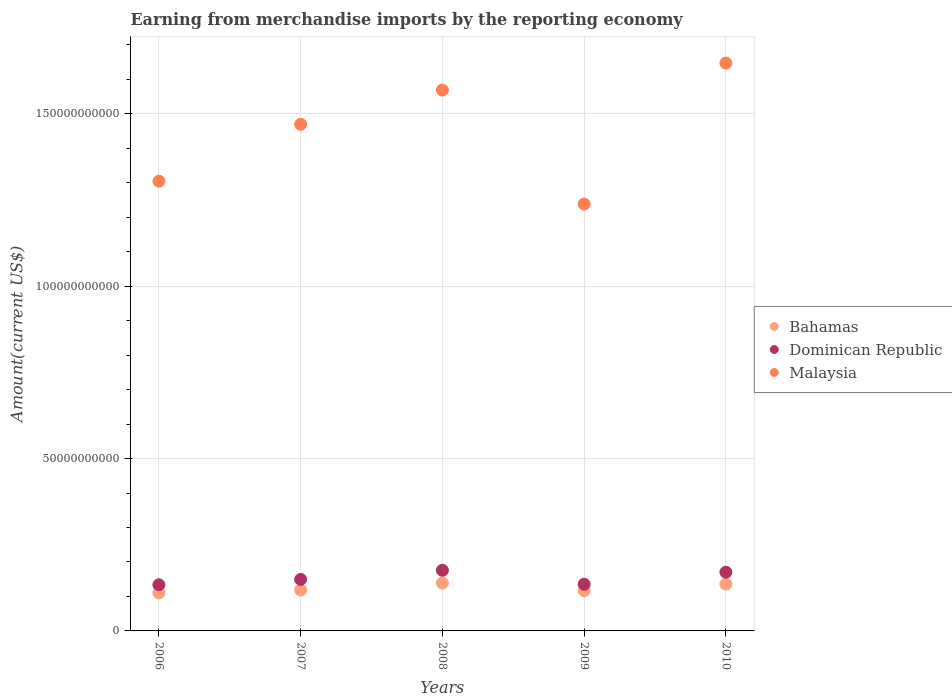Is the number of dotlines equal to the number of legend labels?
Your answer should be compact. Yes. What is the amount earned from merchandise imports in Dominican Republic in 2010?
Provide a short and direct response. 1.70e+1. Across all years, what is the maximum amount earned from merchandise imports in Dominican Republic?
Offer a very short reply. 1.76e+1. Across all years, what is the minimum amount earned from merchandise imports in Malaysia?
Provide a succinct answer. 1.24e+11. In which year was the amount earned from merchandise imports in Bahamas maximum?
Ensure brevity in your answer.  2008. What is the total amount earned from merchandise imports in Bahamas in the graph?
Offer a terse response. 6.21e+1. What is the difference between the amount earned from merchandise imports in Malaysia in 2007 and that in 2010?
Offer a terse response. -1.78e+1. What is the difference between the amount earned from merchandise imports in Dominican Republic in 2008 and the amount earned from merchandise imports in Bahamas in 2010?
Provide a succinct answer. 4.00e+09. What is the average amount earned from merchandise imports in Bahamas per year?
Your answer should be very brief. 1.24e+1. In the year 2009, what is the difference between the amount earned from merchandise imports in Bahamas and amount earned from merchandise imports in Malaysia?
Offer a terse response. -1.12e+11. In how many years, is the amount earned from merchandise imports in Bahamas greater than 160000000000 US$?
Your response must be concise. 0. What is the ratio of the amount earned from merchandise imports in Malaysia in 2007 to that in 2008?
Provide a short and direct response. 0.94. Is the amount earned from merchandise imports in Dominican Republic in 2006 less than that in 2007?
Provide a short and direct response. Yes. Is the difference between the amount earned from merchandise imports in Bahamas in 2007 and 2008 greater than the difference between the amount earned from merchandise imports in Malaysia in 2007 and 2008?
Your response must be concise. Yes. What is the difference between the highest and the second highest amount earned from merchandise imports in Bahamas?
Your response must be concise. 3.21e+08. What is the difference between the highest and the lowest amount earned from merchandise imports in Dominican Republic?
Your answer should be compact. 4.20e+09. Is it the case that in every year, the sum of the amount earned from merchandise imports in Malaysia and amount earned from merchandise imports in Dominican Republic  is greater than the amount earned from merchandise imports in Bahamas?
Keep it short and to the point. Yes. Is the amount earned from merchandise imports in Dominican Republic strictly less than the amount earned from merchandise imports in Bahamas over the years?
Ensure brevity in your answer.  No. What is the difference between two consecutive major ticks on the Y-axis?
Keep it short and to the point. 5.00e+1. Are the values on the major ticks of Y-axis written in scientific E-notation?
Provide a short and direct response. No. Does the graph contain any zero values?
Give a very brief answer. No. Where does the legend appear in the graph?
Give a very brief answer. Center right. What is the title of the graph?
Offer a terse response. Earning from merchandise imports by the reporting economy. What is the label or title of the Y-axis?
Offer a terse response. Amount(current US$). What is the Amount(current US$) in Bahamas in 2006?
Your response must be concise. 1.10e+1. What is the Amount(current US$) of Dominican Republic in 2006?
Offer a terse response. 1.34e+1. What is the Amount(current US$) in Malaysia in 2006?
Offer a terse response. 1.30e+11. What is the Amount(current US$) in Bahamas in 2007?
Keep it short and to the point. 1.19e+1. What is the Amount(current US$) in Dominican Republic in 2007?
Make the answer very short. 1.50e+1. What is the Amount(current US$) in Malaysia in 2007?
Your answer should be very brief. 1.47e+11. What is the Amount(current US$) of Bahamas in 2008?
Ensure brevity in your answer.  1.39e+1. What is the Amount(current US$) of Dominican Republic in 2008?
Provide a succinct answer. 1.76e+1. What is the Amount(current US$) of Malaysia in 2008?
Provide a succinct answer. 1.57e+11. What is the Amount(current US$) in Bahamas in 2009?
Offer a terse response. 1.17e+1. What is the Amount(current US$) of Dominican Republic in 2009?
Offer a very short reply. 1.35e+1. What is the Amount(current US$) in Malaysia in 2009?
Your response must be concise. 1.24e+11. What is the Amount(current US$) of Bahamas in 2010?
Offer a terse response. 1.36e+1. What is the Amount(current US$) in Dominican Republic in 2010?
Provide a succinct answer. 1.70e+1. What is the Amount(current US$) of Malaysia in 2010?
Make the answer very short. 1.65e+11. Across all years, what is the maximum Amount(current US$) of Bahamas?
Provide a short and direct response. 1.39e+1. Across all years, what is the maximum Amount(current US$) in Dominican Republic?
Your answer should be very brief. 1.76e+1. Across all years, what is the maximum Amount(current US$) in Malaysia?
Provide a succinct answer. 1.65e+11. Across all years, what is the minimum Amount(current US$) in Bahamas?
Your answer should be compact. 1.10e+1. Across all years, what is the minimum Amount(current US$) of Dominican Republic?
Your answer should be very brief. 1.34e+1. Across all years, what is the minimum Amount(current US$) of Malaysia?
Make the answer very short. 1.24e+11. What is the total Amount(current US$) of Bahamas in the graph?
Your response must be concise. 6.21e+1. What is the total Amount(current US$) in Dominican Republic in the graph?
Your answer should be compact. 7.65e+1. What is the total Amount(current US$) of Malaysia in the graph?
Your response must be concise. 7.23e+11. What is the difference between the Amount(current US$) of Bahamas in 2006 and that in 2007?
Your response must be concise. -8.22e+08. What is the difference between the Amount(current US$) of Dominican Republic in 2006 and that in 2007?
Your answer should be very brief. -1.56e+09. What is the difference between the Amount(current US$) in Malaysia in 2006 and that in 2007?
Make the answer very short. -1.65e+1. What is the difference between the Amount(current US$) of Bahamas in 2006 and that in 2008?
Keep it short and to the point. -2.87e+09. What is the difference between the Amount(current US$) of Dominican Republic in 2006 and that in 2008?
Provide a short and direct response. -4.20e+09. What is the difference between the Amount(current US$) of Malaysia in 2006 and that in 2008?
Your response must be concise. -2.64e+1. What is the difference between the Amount(current US$) in Bahamas in 2006 and that in 2009?
Make the answer very short. -6.40e+08. What is the difference between the Amount(current US$) in Dominican Republic in 2006 and that in 2009?
Provide a succinct answer. -1.34e+08. What is the difference between the Amount(current US$) of Malaysia in 2006 and that in 2009?
Your answer should be compact. 6.65e+09. What is the difference between the Amount(current US$) of Bahamas in 2006 and that in 2010?
Provide a short and direct response. -2.55e+09. What is the difference between the Amount(current US$) of Dominican Republic in 2006 and that in 2010?
Your answer should be very brief. -3.65e+09. What is the difference between the Amount(current US$) in Malaysia in 2006 and that in 2010?
Make the answer very short. -3.43e+1. What is the difference between the Amount(current US$) in Bahamas in 2007 and that in 2008?
Provide a short and direct response. -2.05e+09. What is the difference between the Amount(current US$) in Dominican Republic in 2007 and that in 2008?
Provide a short and direct response. -2.64e+09. What is the difference between the Amount(current US$) of Malaysia in 2007 and that in 2008?
Give a very brief answer. -9.91e+09. What is the difference between the Amount(current US$) in Bahamas in 2007 and that in 2009?
Your answer should be very brief. 1.82e+08. What is the difference between the Amount(current US$) in Dominican Republic in 2007 and that in 2009?
Offer a very short reply. 1.43e+09. What is the difference between the Amount(current US$) in Malaysia in 2007 and that in 2009?
Give a very brief answer. 2.32e+1. What is the difference between the Amount(current US$) in Bahamas in 2007 and that in 2010?
Offer a terse response. -1.73e+09. What is the difference between the Amount(current US$) in Dominican Republic in 2007 and that in 2010?
Make the answer very short. -2.08e+09. What is the difference between the Amount(current US$) of Malaysia in 2007 and that in 2010?
Offer a very short reply. -1.78e+1. What is the difference between the Amount(current US$) of Bahamas in 2008 and that in 2009?
Offer a very short reply. 2.23e+09. What is the difference between the Amount(current US$) of Dominican Republic in 2008 and that in 2009?
Your answer should be compact. 4.07e+09. What is the difference between the Amount(current US$) in Malaysia in 2008 and that in 2009?
Keep it short and to the point. 3.31e+1. What is the difference between the Amount(current US$) of Bahamas in 2008 and that in 2010?
Give a very brief answer. 3.21e+08. What is the difference between the Amount(current US$) of Dominican Republic in 2008 and that in 2010?
Provide a succinct answer. 5.54e+08. What is the difference between the Amount(current US$) of Malaysia in 2008 and that in 2010?
Offer a terse response. -7.84e+09. What is the difference between the Amount(current US$) of Bahamas in 2009 and that in 2010?
Keep it short and to the point. -1.91e+09. What is the difference between the Amount(current US$) in Dominican Republic in 2009 and that in 2010?
Offer a very short reply. -3.51e+09. What is the difference between the Amount(current US$) in Malaysia in 2009 and that in 2010?
Provide a short and direct response. -4.09e+1. What is the difference between the Amount(current US$) in Bahamas in 2006 and the Amount(current US$) in Dominican Republic in 2007?
Your answer should be very brief. -3.91e+09. What is the difference between the Amount(current US$) in Bahamas in 2006 and the Amount(current US$) in Malaysia in 2007?
Offer a very short reply. -1.36e+11. What is the difference between the Amount(current US$) in Dominican Republic in 2006 and the Amount(current US$) in Malaysia in 2007?
Offer a very short reply. -1.34e+11. What is the difference between the Amount(current US$) in Bahamas in 2006 and the Amount(current US$) in Dominican Republic in 2008?
Provide a succinct answer. -6.55e+09. What is the difference between the Amount(current US$) in Bahamas in 2006 and the Amount(current US$) in Malaysia in 2008?
Your answer should be very brief. -1.46e+11. What is the difference between the Amount(current US$) of Dominican Republic in 2006 and the Amount(current US$) of Malaysia in 2008?
Your response must be concise. -1.44e+11. What is the difference between the Amount(current US$) in Bahamas in 2006 and the Amount(current US$) in Dominican Republic in 2009?
Your answer should be compact. -2.48e+09. What is the difference between the Amount(current US$) in Bahamas in 2006 and the Amount(current US$) in Malaysia in 2009?
Provide a short and direct response. -1.13e+11. What is the difference between the Amount(current US$) in Dominican Republic in 2006 and the Amount(current US$) in Malaysia in 2009?
Ensure brevity in your answer.  -1.10e+11. What is the difference between the Amount(current US$) in Bahamas in 2006 and the Amount(current US$) in Dominican Republic in 2010?
Your response must be concise. -5.99e+09. What is the difference between the Amount(current US$) in Bahamas in 2006 and the Amount(current US$) in Malaysia in 2010?
Give a very brief answer. -1.54e+11. What is the difference between the Amount(current US$) of Dominican Republic in 2006 and the Amount(current US$) of Malaysia in 2010?
Your answer should be compact. -1.51e+11. What is the difference between the Amount(current US$) of Bahamas in 2007 and the Amount(current US$) of Dominican Republic in 2008?
Your answer should be very brief. -5.73e+09. What is the difference between the Amount(current US$) of Bahamas in 2007 and the Amount(current US$) of Malaysia in 2008?
Make the answer very short. -1.45e+11. What is the difference between the Amount(current US$) of Dominican Republic in 2007 and the Amount(current US$) of Malaysia in 2008?
Keep it short and to the point. -1.42e+11. What is the difference between the Amount(current US$) of Bahamas in 2007 and the Amount(current US$) of Dominican Republic in 2009?
Offer a very short reply. -1.66e+09. What is the difference between the Amount(current US$) of Bahamas in 2007 and the Amount(current US$) of Malaysia in 2009?
Ensure brevity in your answer.  -1.12e+11. What is the difference between the Amount(current US$) of Dominican Republic in 2007 and the Amount(current US$) of Malaysia in 2009?
Your response must be concise. -1.09e+11. What is the difference between the Amount(current US$) of Bahamas in 2007 and the Amount(current US$) of Dominican Republic in 2010?
Your answer should be very brief. -5.17e+09. What is the difference between the Amount(current US$) in Bahamas in 2007 and the Amount(current US$) in Malaysia in 2010?
Keep it short and to the point. -1.53e+11. What is the difference between the Amount(current US$) in Dominican Republic in 2007 and the Amount(current US$) in Malaysia in 2010?
Make the answer very short. -1.50e+11. What is the difference between the Amount(current US$) in Bahamas in 2008 and the Amount(current US$) in Dominican Republic in 2009?
Keep it short and to the point. 3.92e+08. What is the difference between the Amount(current US$) of Bahamas in 2008 and the Amount(current US$) of Malaysia in 2009?
Provide a short and direct response. -1.10e+11. What is the difference between the Amount(current US$) of Dominican Republic in 2008 and the Amount(current US$) of Malaysia in 2009?
Provide a succinct answer. -1.06e+11. What is the difference between the Amount(current US$) of Bahamas in 2008 and the Amount(current US$) of Dominican Republic in 2010?
Provide a short and direct response. -3.12e+09. What is the difference between the Amount(current US$) of Bahamas in 2008 and the Amount(current US$) of Malaysia in 2010?
Your response must be concise. -1.51e+11. What is the difference between the Amount(current US$) in Dominican Republic in 2008 and the Amount(current US$) in Malaysia in 2010?
Keep it short and to the point. -1.47e+11. What is the difference between the Amount(current US$) of Bahamas in 2009 and the Amount(current US$) of Dominican Republic in 2010?
Provide a short and direct response. -5.35e+09. What is the difference between the Amount(current US$) in Bahamas in 2009 and the Amount(current US$) in Malaysia in 2010?
Ensure brevity in your answer.  -1.53e+11. What is the difference between the Amount(current US$) of Dominican Republic in 2009 and the Amount(current US$) of Malaysia in 2010?
Provide a succinct answer. -1.51e+11. What is the average Amount(current US$) of Bahamas per year?
Provide a succinct answer. 1.24e+1. What is the average Amount(current US$) of Dominican Republic per year?
Offer a very short reply. 1.53e+1. What is the average Amount(current US$) of Malaysia per year?
Your answer should be very brief. 1.45e+11. In the year 2006, what is the difference between the Amount(current US$) of Bahamas and Amount(current US$) of Dominican Republic?
Your answer should be very brief. -2.35e+09. In the year 2006, what is the difference between the Amount(current US$) of Bahamas and Amount(current US$) of Malaysia?
Make the answer very short. -1.19e+11. In the year 2006, what is the difference between the Amount(current US$) of Dominican Republic and Amount(current US$) of Malaysia?
Offer a terse response. -1.17e+11. In the year 2007, what is the difference between the Amount(current US$) in Bahamas and Amount(current US$) in Dominican Republic?
Offer a terse response. -3.09e+09. In the year 2007, what is the difference between the Amount(current US$) in Bahamas and Amount(current US$) in Malaysia?
Offer a terse response. -1.35e+11. In the year 2007, what is the difference between the Amount(current US$) of Dominican Republic and Amount(current US$) of Malaysia?
Make the answer very short. -1.32e+11. In the year 2008, what is the difference between the Amount(current US$) in Bahamas and Amount(current US$) in Dominican Republic?
Keep it short and to the point. -3.67e+09. In the year 2008, what is the difference between the Amount(current US$) in Bahamas and Amount(current US$) in Malaysia?
Ensure brevity in your answer.  -1.43e+11. In the year 2008, what is the difference between the Amount(current US$) of Dominican Republic and Amount(current US$) of Malaysia?
Give a very brief answer. -1.39e+11. In the year 2009, what is the difference between the Amount(current US$) in Bahamas and Amount(current US$) in Dominican Republic?
Your answer should be very brief. -1.84e+09. In the year 2009, what is the difference between the Amount(current US$) in Bahamas and Amount(current US$) in Malaysia?
Make the answer very short. -1.12e+11. In the year 2009, what is the difference between the Amount(current US$) in Dominican Republic and Amount(current US$) in Malaysia?
Your answer should be very brief. -1.10e+11. In the year 2010, what is the difference between the Amount(current US$) of Bahamas and Amount(current US$) of Dominican Republic?
Ensure brevity in your answer.  -3.44e+09. In the year 2010, what is the difference between the Amount(current US$) of Bahamas and Amount(current US$) of Malaysia?
Your response must be concise. -1.51e+11. In the year 2010, what is the difference between the Amount(current US$) in Dominican Republic and Amount(current US$) in Malaysia?
Make the answer very short. -1.48e+11. What is the ratio of the Amount(current US$) of Bahamas in 2006 to that in 2007?
Your answer should be very brief. 0.93. What is the ratio of the Amount(current US$) in Dominican Republic in 2006 to that in 2007?
Offer a very short reply. 0.9. What is the ratio of the Amount(current US$) of Malaysia in 2006 to that in 2007?
Your answer should be compact. 0.89. What is the ratio of the Amount(current US$) of Bahamas in 2006 to that in 2008?
Provide a short and direct response. 0.79. What is the ratio of the Amount(current US$) in Dominican Republic in 2006 to that in 2008?
Your response must be concise. 0.76. What is the ratio of the Amount(current US$) in Malaysia in 2006 to that in 2008?
Keep it short and to the point. 0.83. What is the ratio of the Amount(current US$) in Bahamas in 2006 to that in 2009?
Ensure brevity in your answer.  0.95. What is the ratio of the Amount(current US$) in Dominican Republic in 2006 to that in 2009?
Offer a very short reply. 0.99. What is the ratio of the Amount(current US$) of Malaysia in 2006 to that in 2009?
Make the answer very short. 1.05. What is the ratio of the Amount(current US$) in Bahamas in 2006 to that in 2010?
Offer a very short reply. 0.81. What is the ratio of the Amount(current US$) in Dominican Republic in 2006 to that in 2010?
Offer a very short reply. 0.79. What is the ratio of the Amount(current US$) in Malaysia in 2006 to that in 2010?
Your answer should be very brief. 0.79. What is the ratio of the Amount(current US$) of Bahamas in 2007 to that in 2008?
Make the answer very short. 0.85. What is the ratio of the Amount(current US$) of Dominican Republic in 2007 to that in 2008?
Provide a short and direct response. 0.85. What is the ratio of the Amount(current US$) in Malaysia in 2007 to that in 2008?
Ensure brevity in your answer.  0.94. What is the ratio of the Amount(current US$) in Bahamas in 2007 to that in 2009?
Your response must be concise. 1.02. What is the ratio of the Amount(current US$) in Dominican Republic in 2007 to that in 2009?
Give a very brief answer. 1.11. What is the ratio of the Amount(current US$) of Malaysia in 2007 to that in 2009?
Your answer should be compact. 1.19. What is the ratio of the Amount(current US$) in Bahamas in 2007 to that in 2010?
Give a very brief answer. 0.87. What is the ratio of the Amount(current US$) in Dominican Republic in 2007 to that in 2010?
Your answer should be compact. 0.88. What is the ratio of the Amount(current US$) of Malaysia in 2007 to that in 2010?
Your response must be concise. 0.89. What is the ratio of the Amount(current US$) in Bahamas in 2008 to that in 2009?
Offer a very short reply. 1.19. What is the ratio of the Amount(current US$) in Dominican Republic in 2008 to that in 2009?
Ensure brevity in your answer.  1.3. What is the ratio of the Amount(current US$) of Malaysia in 2008 to that in 2009?
Give a very brief answer. 1.27. What is the ratio of the Amount(current US$) in Bahamas in 2008 to that in 2010?
Keep it short and to the point. 1.02. What is the ratio of the Amount(current US$) of Dominican Republic in 2008 to that in 2010?
Provide a succinct answer. 1.03. What is the ratio of the Amount(current US$) of Bahamas in 2009 to that in 2010?
Make the answer very short. 0.86. What is the ratio of the Amount(current US$) of Dominican Republic in 2009 to that in 2010?
Your response must be concise. 0.79. What is the ratio of the Amount(current US$) in Malaysia in 2009 to that in 2010?
Make the answer very short. 0.75. What is the difference between the highest and the second highest Amount(current US$) in Bahamas?
Make the answer very short. 3.21e+08. What is the difference between the highest and the second highest Amount(current US$) in Dominican Republic?
Provide a succinct answer. 5.54e+08. What is the difference between the highest and the second highest Amount(current US$) of Malaysia?
Offer a terse response. 7.84e+09. What is the difference between the highest and the lowest Amount(current US$) of Bahamas?
Keep it short and to the point. 2.87e+09. What is the difference between the highest and the lowest Amount(current US$) of Dominican Republic?
Give a very brief answer. 4.20e+09. What is the difference between the highest and the lowest Amount(current US$) in Malaysia?
Offer a terse response. 4.09e+1. 